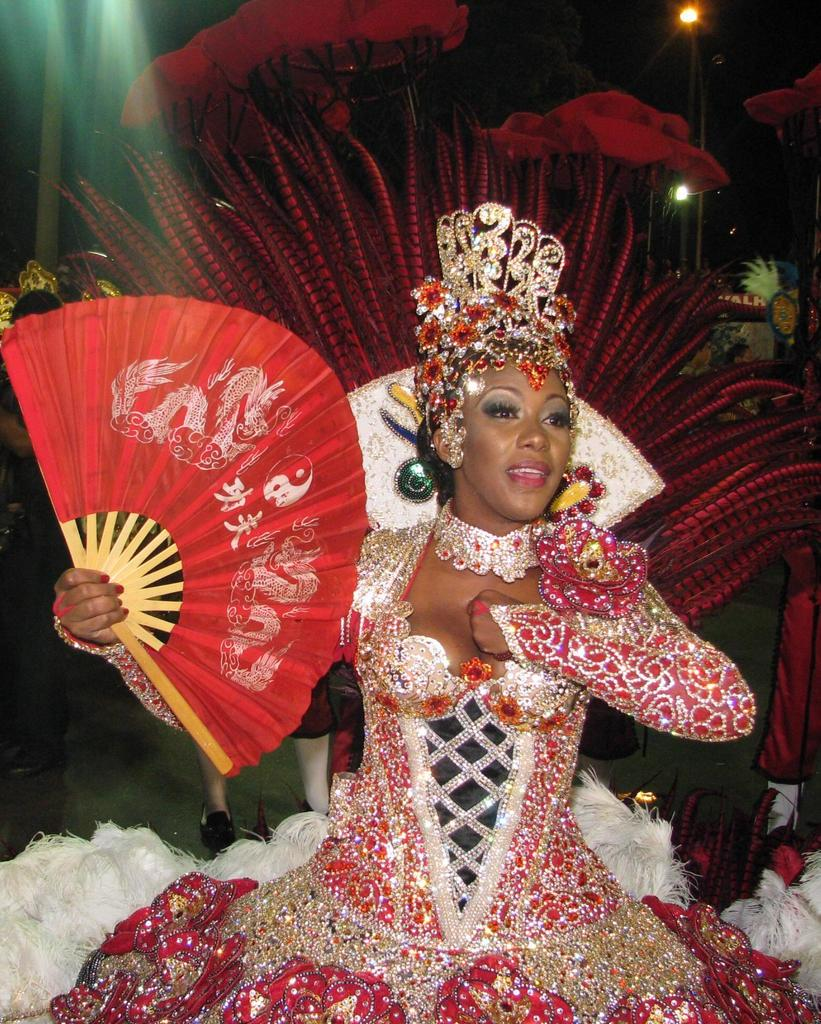Who is present in the image? There is a woman in the image. What is the woman holding in the image? The woman is holding a hand fan. What is the woman's facial expression in the image? The woman is smiling. What can be seen in the background of the image? There are people's legs, poles, lights, and some objects visible in the background. How would you describe the lighting in the background? The background is dark. What type of feather can be seen on the woman's hat in the image? There is no feather visible on the woman's hat in the image. What time of day is it in the image? The time of day cannot be determined from the image alone, as there are no specific time-related cues present. 